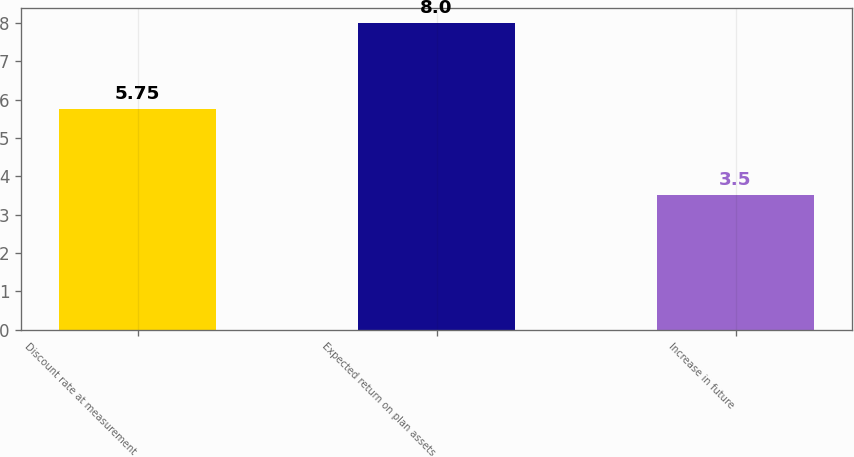Convert chart to OTSL. <chart><loc_0><loc_0><loc_500><loc_500><bar_chart><fcel>Discount rate at measurement<fcel>Expected return on plan assets<fcel>Increase in future<nl><fcel>5.75<fcel>8<fcel>3.5<nl></chart> 